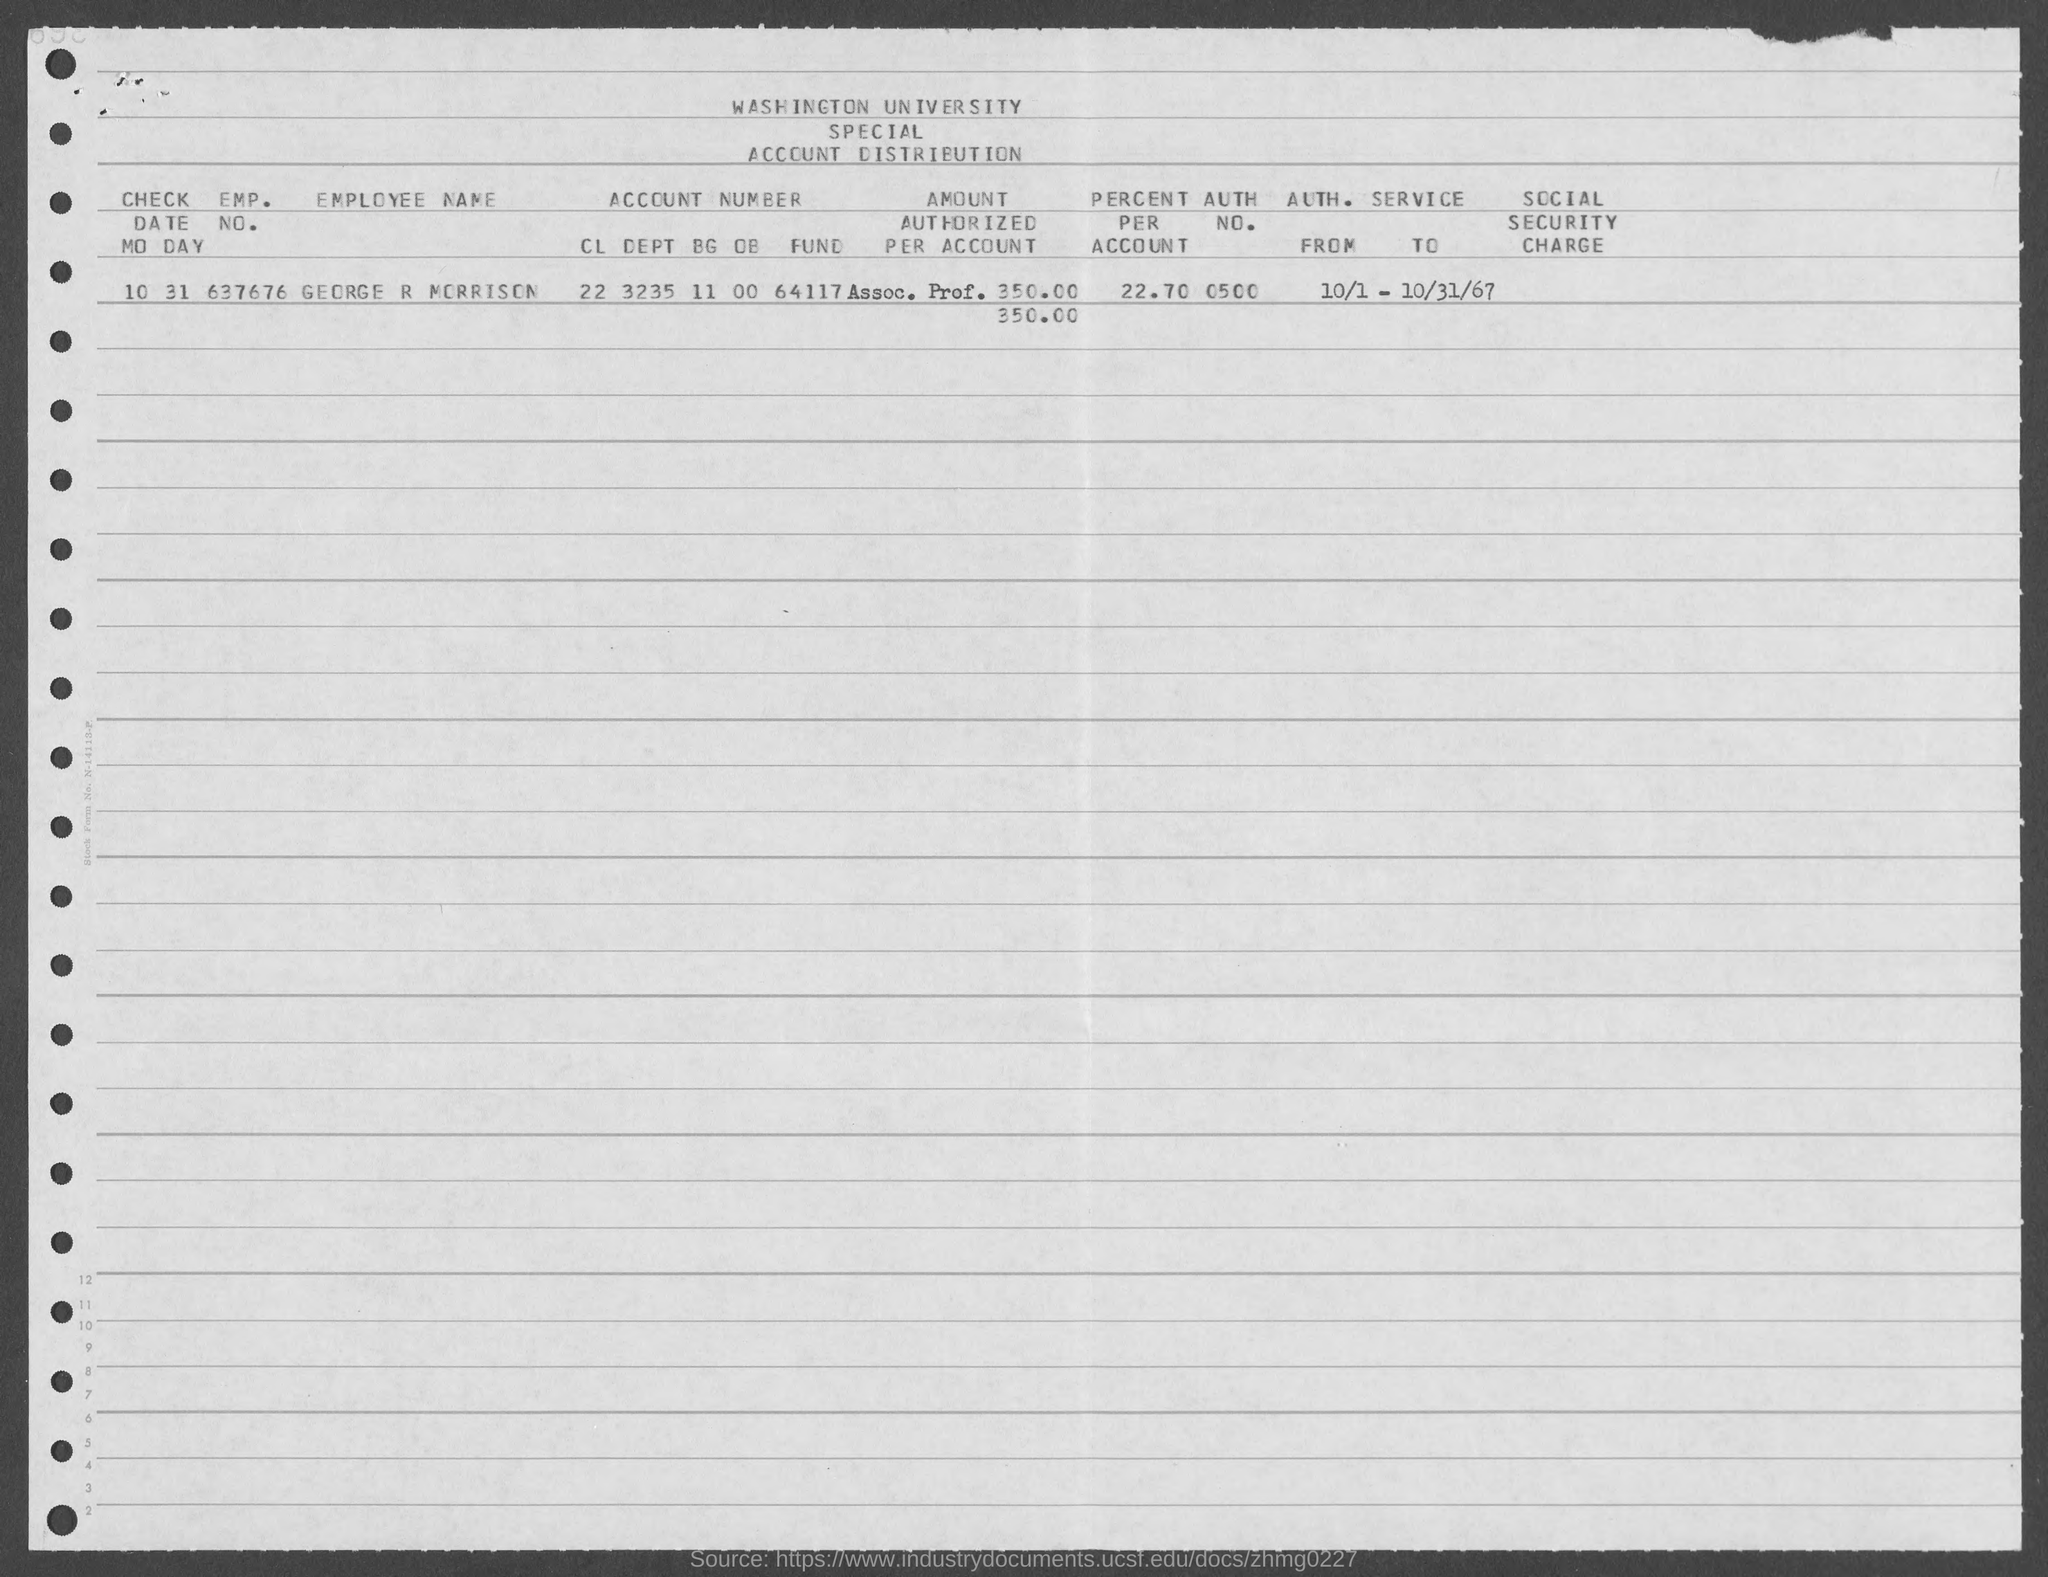Identify some key points in this picture. The employment number of George R Morrison is 637676. What is the check date for MO DAY: 10/31? George R Morrison holds 22.70% of the total accounts. 